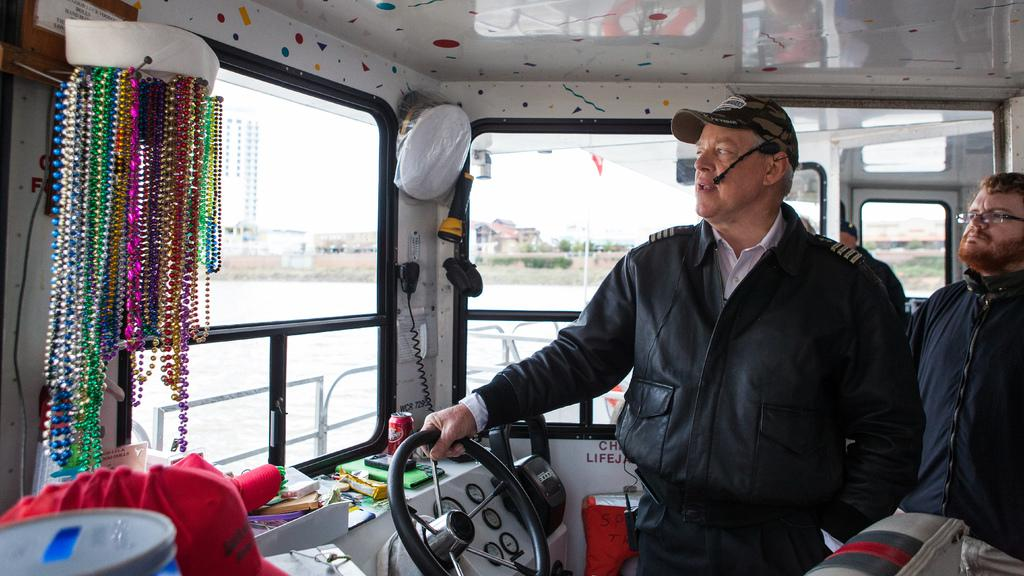What is the main subject of the image? The main subject of the image is a ship. Where is the ship located in the image? The ship is on the water. How many people are on the ship? There are two persons in the ship. What type of equipment is present in the ship? There are meters in the ship. What type of items can be found in the ship? There are tins and other objects in the ship. What can be seen in the background of the image? Buildings, trees, and the sky are visible in the image. Can you tell me how many chess pieces are on the table in the image? There is no table or chess pieces present in the image; it features a ship on the water. How many books are visible in the image? There are no books visible in the image; it features a ship on the water. 